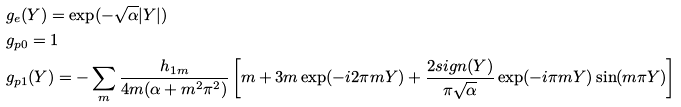Convert formula to latex. <formula><loc_0><loc_0><loc_500><loc_500>& g _ { e } ( Y ) = \exp ( - \sqrt { \alpha } | Y | ) \\ & g _ { p 0 } = 1 \\ & g _ { p 1 } ( Y ) = - \sum _ { m } \frac { h _ { 1 m } } { 4 m ( \alpha + m ^ { 2 } \pi ^ { 2 } ) } \left [ m + 3 m \exp ( - i 2 \pi m Y ) + \frac { 2 s i g n ( Y ) } { \pi \sqrt { \alpha } } \exp ( - i \pi m Y ) \sin ( m \pi Y ) \right ]</formula> 